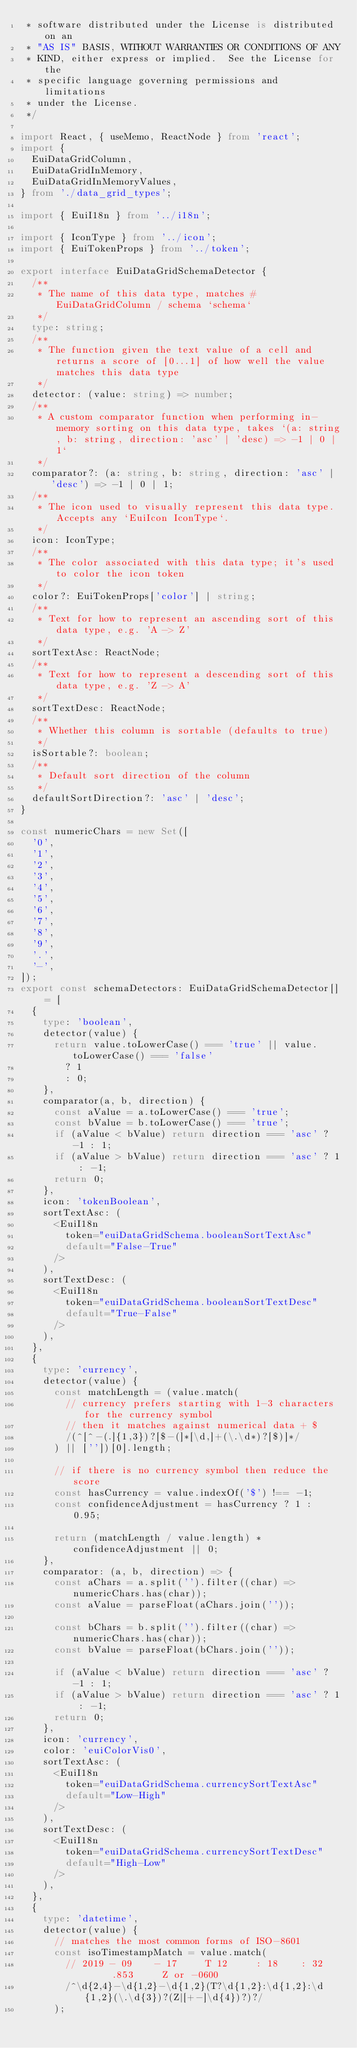Convert code to text. <code><loc_0><loc_0><loc_500><loc_500><_TypeScript_> * software distributed under the License is distributed on an
 * "AS IS" BASIS, WITHOUT WARRANTIES OR CONDITIONS OF ANY
 * KIND, either express or implied.  See the License for the
 * specific language governing permissions and limitations
 * under the License.
 */

import React, { useMemo, ReactNode } from 'react';
import {
  EuiDataGridColumn,
  EuiDataGridInMemory,
  EuiDataGridInMemoryValues,
} from './data_grid_types';

import { EuiI18n } from '../i18n';

import { IconType } from '../icon';
import { EuiTokenProps } from '../token';

export interface EuiDataGridSchemaDetector {
  /**
   * The name of this data type, matches #EuiDataGridColumn / schema `schema`
   */
  type: string;
  /**
   * The function given the text value of a cell and returns a score of [0...1] of how well the value matches this data type
   */
  detector: (value: string) => number;
  /**
   * A custom comparator function when performing in-memory sorting on this data type, takes `(a: string, b: string, direction: 'asc' | 'desc) => -1 | 0 | 1`
   */
  comparator?: (a: string, b: string, direction: 'asc' | 'desc') => -1 | 0 | 1;
  /**
   * The icon used to visually represent this data type. Accepts any `EuiIcon IconType`.
   */
  icon: IconType;
  /**
   * The color associated with this data type; it's used to color the icon token
   */
  color?: EuiTokenProps['color'] | string;
  /**
   * Text for how to represent an ascending sort of this data type, e.g. 'A -> Z'
   */
  sortTextAsc: ReactNode;
  /**
   * Text for how to represent a descending sort of this data type, e.g. 'Z -> A'
   */
  sortTextDesc: ReactNode;
  /**
   * Whether this column is sortable (defaults to true)
   */
  isSortable?: boolean;
  /**
   * Default sort direction of the column
   */
  defaultSortDirection?: 'asc' | 'desc';
}

const numericChars = new Set([
  '0',
  '1',
  '2',
  '3',
  '4',
  '5',
  '6',
  '7',
  '8',
  '9',
  '.',
  '-',
]);
export const schemaDetectors: EuiDataGridSchemaDetector[] = [
  {
    type: 'boolean',
    detector(value) {
      return value.toLowerCase() === 'true' || value.toLowerCase() === 'false'
        ? 1
        : 0;
    },
    comparator(a, b, direction) {
      const aValue = a.toLowerCase() === 'true';
      const bValue = b.toLowerCase() === 'true';
      if (aValue < bValue) return direction === 'asc' ? -1 : 1;
      if (aValue > bValue) return direction === 'asc' ? 1 : -1;
      return 0;
    },
    icon: 'tokenBoolean',
    sortTextAsc: (
      <EuiI18n
        token="euiDataGridSchema.booleanSortTextAsc"
        default="False-True"
      />
    ),
    sortTextDesc: (
      <EuiI18n
        token="euiDataGridSchema.booleanSortTextDesc"
        default="True-False"
      />
    ),
  },
  {
    type: 'currency',
    detector(value) {
      const matchLength = (value.match(
        // currency prefers starting with 1-3 characters for the currency symbol
        // then it matches against numerical data + $
        /(^[^-(.]{1,3})?[$-(]*[\d,]+(\.\d*)?[$)]*/
      ) || [''])[0].length;

      // if there is no currency symbol then reduce the score
      const hasCurrency = value.indexOf('$') !== -1;
      const confidenceAdjustment = hasCurrency ? 1 : 0.95;

      return (matchLength / value.length) * confidenceAdjustment || 0;
    },
    comparator: (a, b, direction) => {
      const aChars = a.split('').filter((char) => numericChars.has(char));
      const aValue = parseFloat(aChars.join(''));

      const bChars = b.split('').filter((char) => numericChars.has(char));
      const bValue = parseFloat(bChars.join(''));

      if (aValue < bValue) return direction === 'asc' ? -1 : 1;
      if (aValue > bValue) return direction === 'asc' ? 1 : -1;
      return 0;
    },
    icon: 'currency',
    color: 'euiColorVis0',
    sortTextAsc: (
      <EuiI18n
        token="euiDataGridSchema.currencySortTextAsc"
        default="Low-High"
      />
    ),
    sortTextDesc: (
      <EuiI18n
        token="euiDataGridSchema.currencySortTextDesc"
        default="High-Low"
      />
    ),
  },
  {
    type: 'datetime',
    detector(value) {
      // matches the most common forms of ISO-8601
      const isoTimestampMatch = value.match(
        // 2019 - 09    - 17     T 12     : 18    : 32      .853     Z or -0600
        /^\d{2,4}-\d{1,2}-\d{1,2}(T?\d{1,2}:\d{1,2}:\d{1,2}(\.\d{3})?(Z|[+-]\d{4})?)?/
      );
</code> 